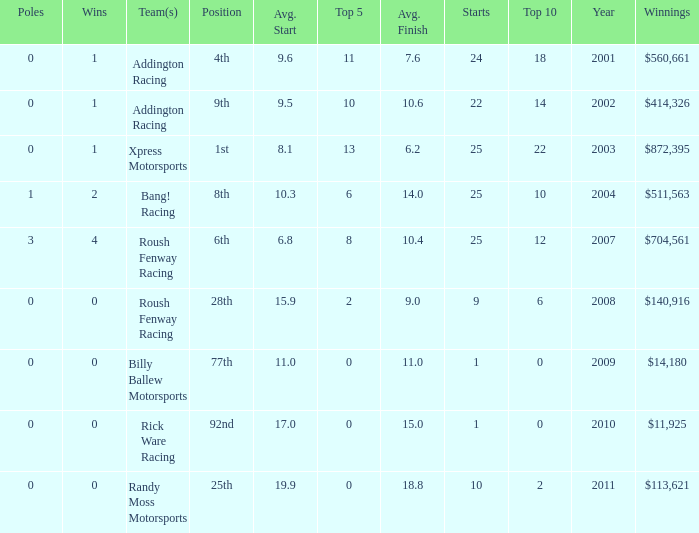What team or teams with 18 in the top 10? Addington Racing. 